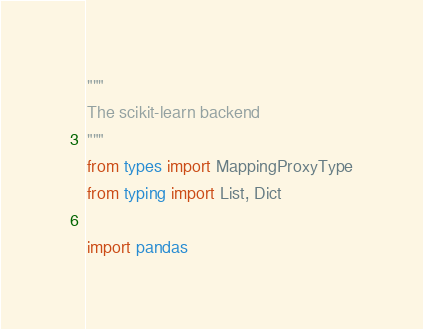<code> <loc_0><loc_0><loc_500><loc_500><_Python_>"""
The scikit-learn backend
"""
from types import MappingProxyType
from typing import List, Dict

import pandas
</code> 